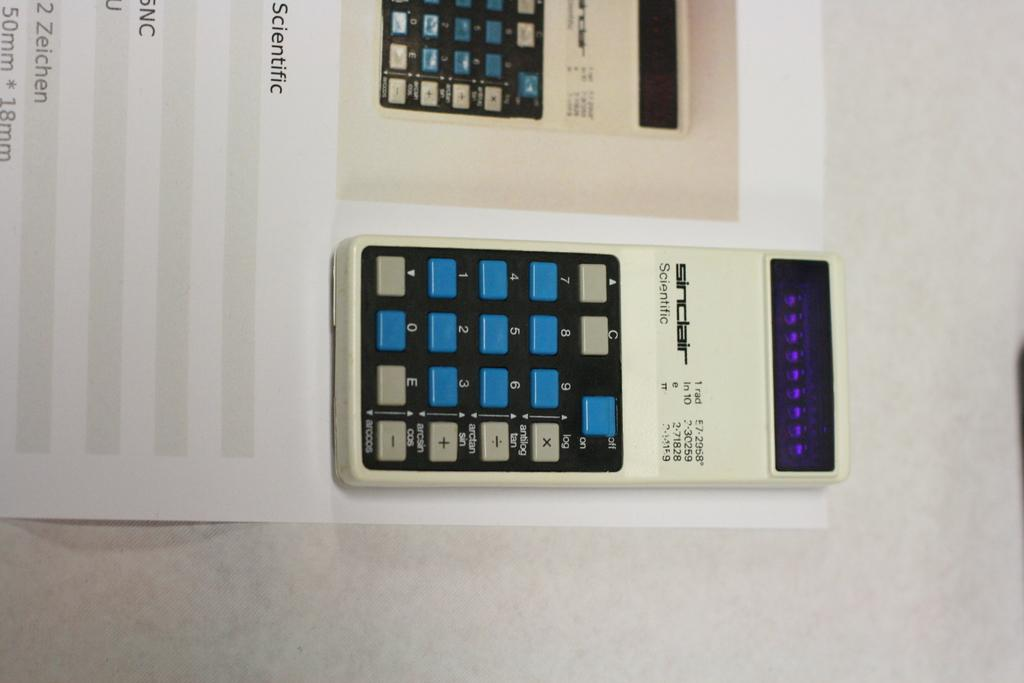<image>
Write a terse but informative summary of the picture. A Sinclair scientific calculator is resting on its manual. 